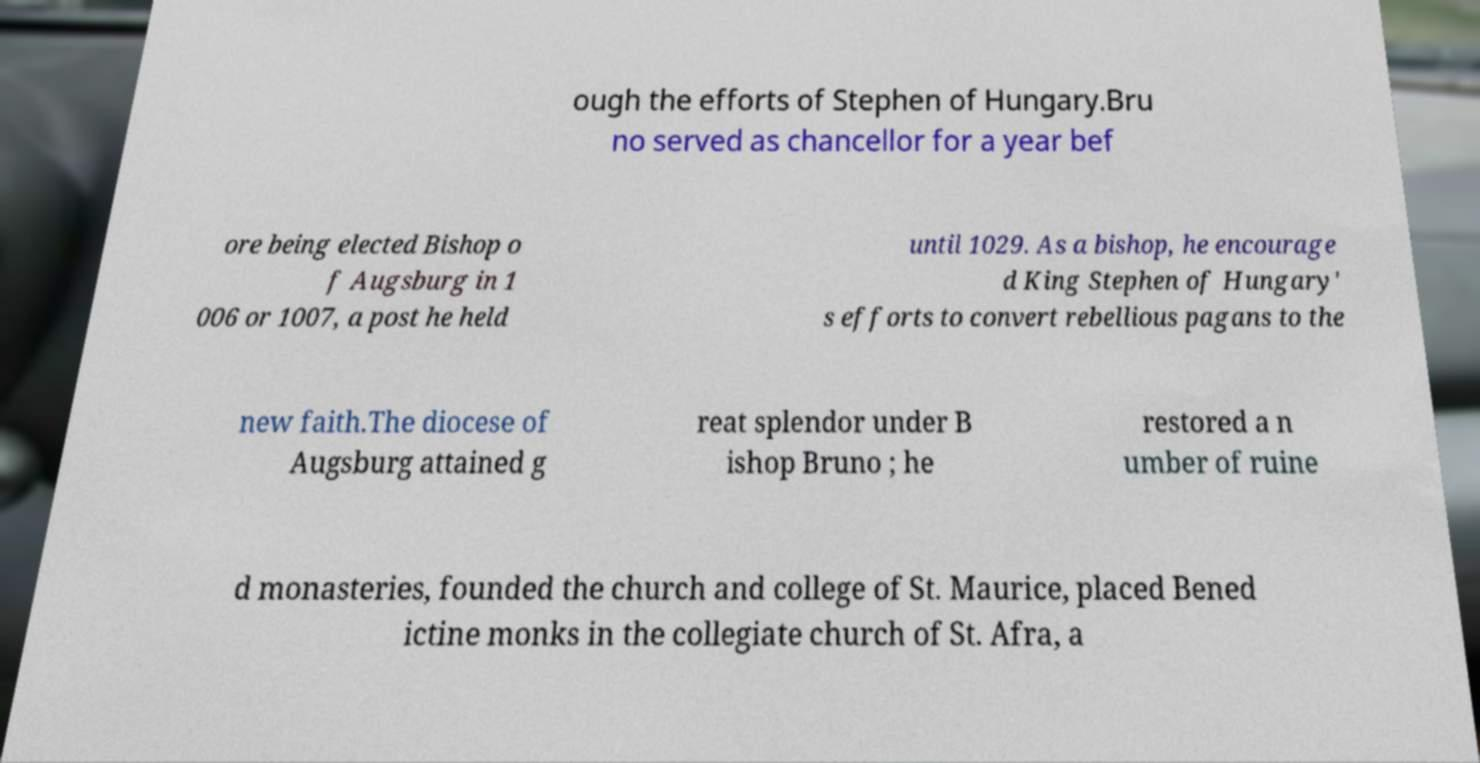There's text embedded in this image that I need extracted. Can you transcribe it verbatim? ough the efforts of Stephen of Hungary.Bru no served as chancellor for a year bef ore being elected Bishop o f Augsburg in 1 006 or 1007, a post he held until 1029. As a bishop, he encourage d King Stephen of Hungary' s efforts to convert rebellious pagans to the new faith.The diocese of Augsburg attained g reat splendor under B ishop Bruno ; he restored a n umber of ruine d monasteries, founded the church and college of St. Maurice, placed Bened ictine monks in the collegiate church of St. Afra, a 